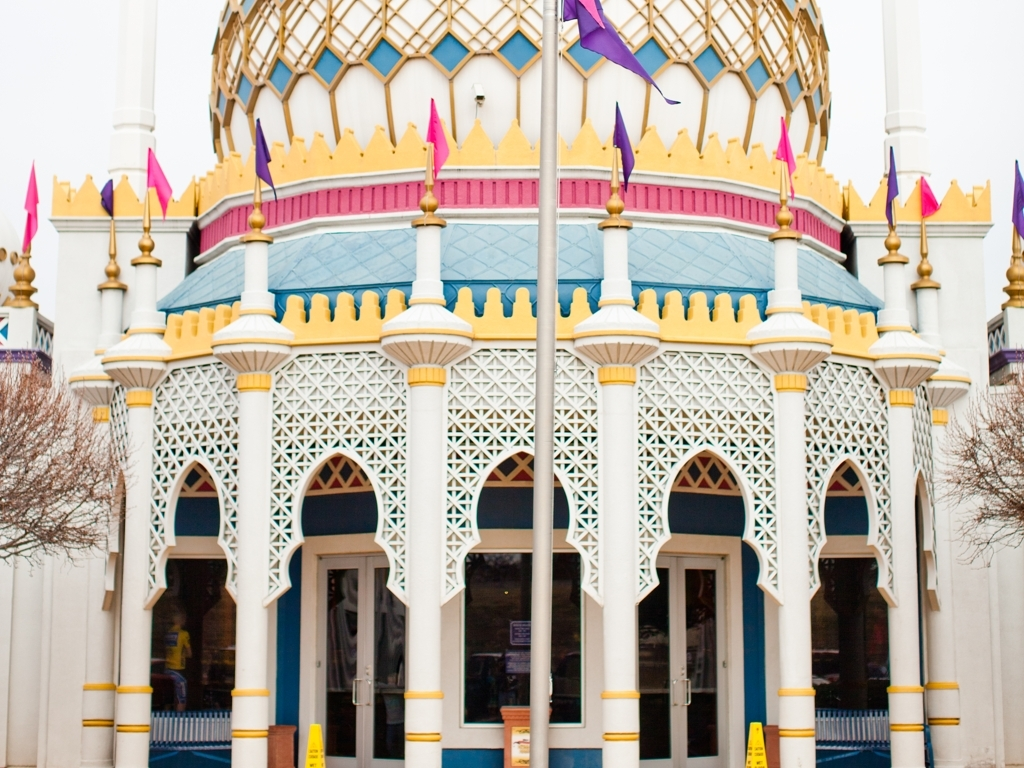Are there any quality issues with this image? While the image is clear and well-composed, there may be some concerns with the central alignment due to the pole interfering with the symmetry. Additionally, the overcast sky results in flat lighting which can affect the vibrancy of the colors. 